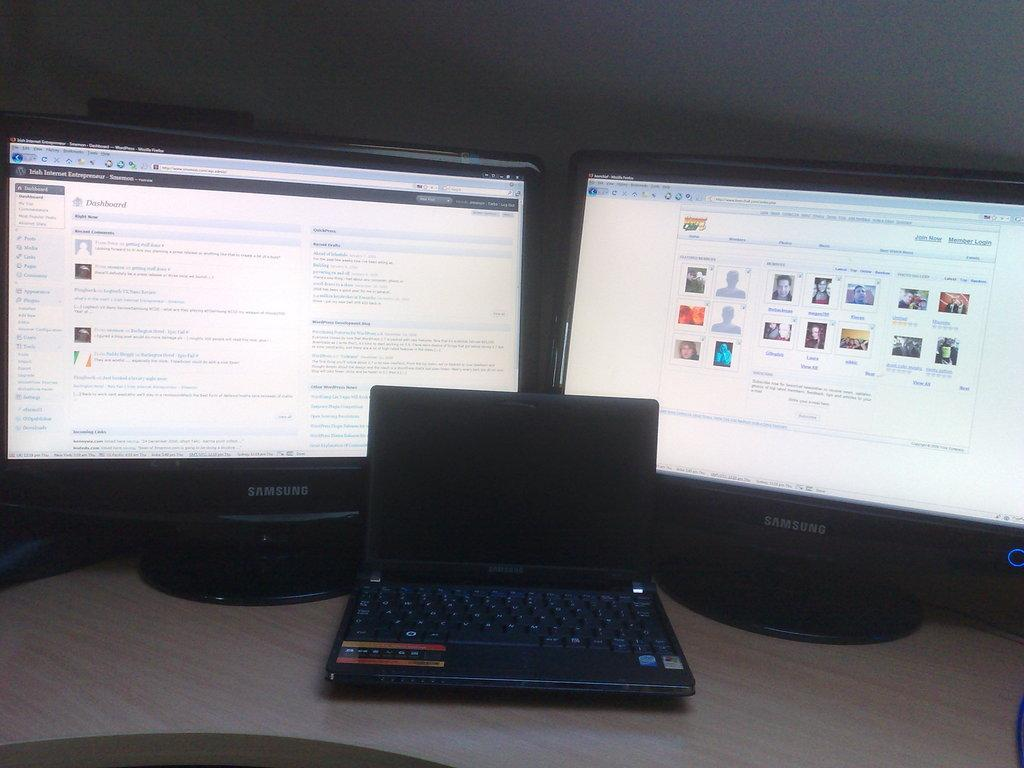<image>
Summarize the visual content of the image. Two samsung computers turned on and laptop turned off 